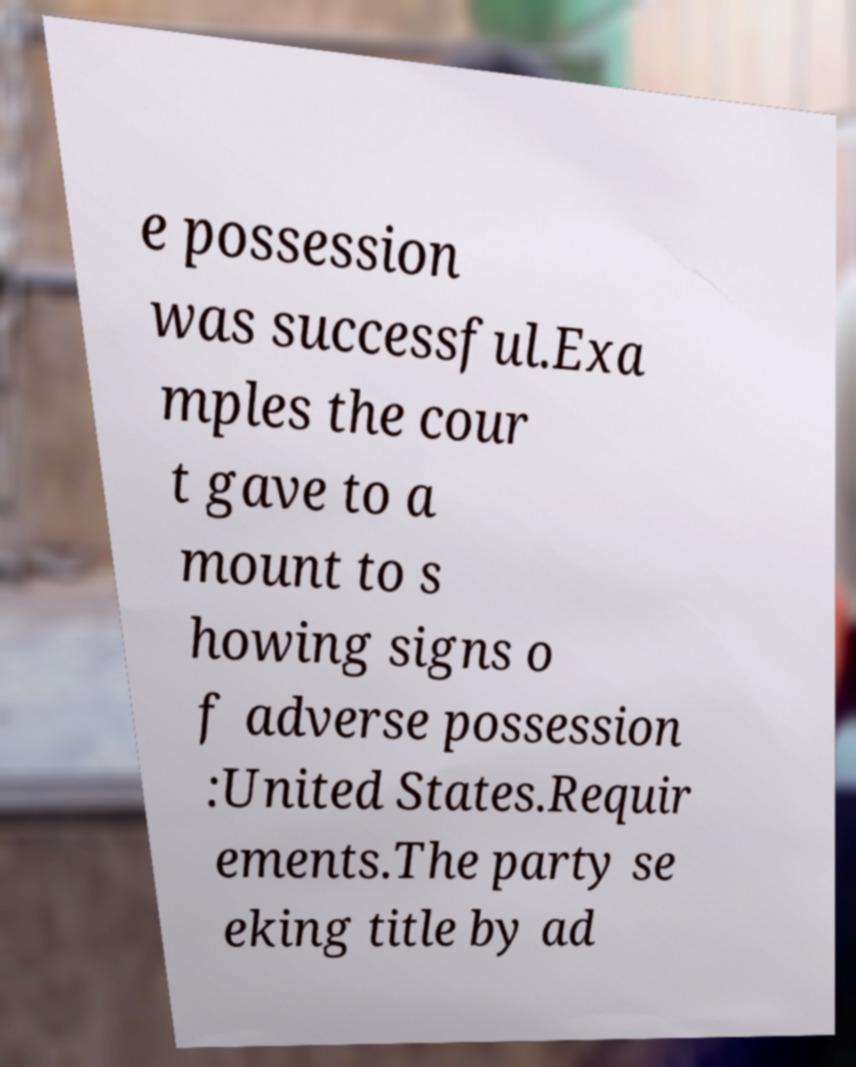What messages or text are displayed in this image? I need them in a readable, typed format. e possession was successful.Exa mples the cour t gave to a mount to s howing signs o f adverse possession :United States.Requir ements.The party se eking title by ad 